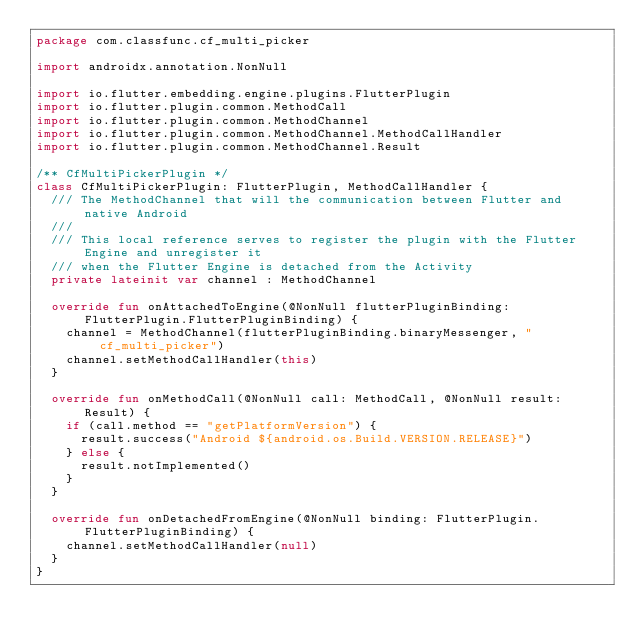<code> <loc_0><loc_0><loc_500><loc_500><_Kotlin_>package com.classfunc.cf_multi_picker

import androidx.annotation.NonNull

import io.flutter.embedding.engine.plugins.FlutterPlugin
import io.flutter.plugin.common.MethodCall
import io.flutter.plugin.common.MethodChannel
import io.flutter.plugin.common.MethodChannel.MethodCallHandler
import io.flutter.plugin.common.MethodChannel.Result

/** CfMultiPickerPlugin */
class CfMultiPickerPlugin: FlutterPlugin, MethodCallHandler {
  /// The MethodChannel that will the communication between Flutter and native Android
  ///
  /// This local reference serves to register the plugin with the Flutter Engine and unregister it
  /// when the Flutter Engine is detached from the Activity
  private lateinit var channel : MethodChannel

  override fun onAttachedToEngine(@NonNull flutterPluginBinding: FlutterPlugin.FlutterPluginBinding) {
    channel = MethodChannel(flutterPluginBinding.binaryMessenger, "cf_multi_picker")
    channel.setMethodCallHandler(this)
  }

  override fun onMethodCall(@NonNull call: MethodCall, @NonNull result: Result) {
    if (call.method == "getPlatformVersion") {
      result.success("Android ${android.os.Build.VERSION.RELEASE}")
    } else {
      result.notImplemented()
    }
  }

  override fun onDetachedFromEngine(@NonNull binding: FlutterPlugin.FlutterPluginBinding) {
    channel.setMethodCallHandler(null)
  }
}
</code> 